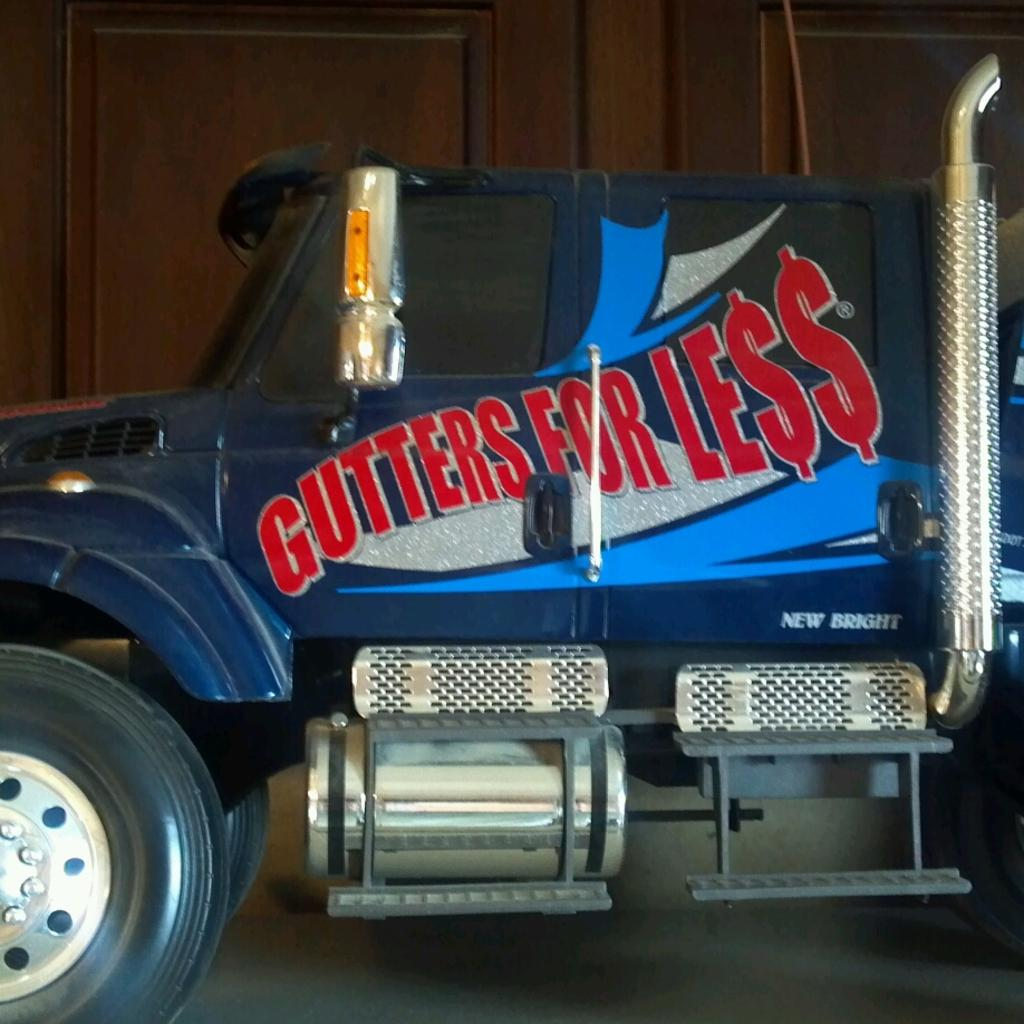What is the main subject of the image? There is a vehicle in the image. Can you describe any specific features of the vehicle? The vehicle has some text on it. What type of surface is visible in the image? There is ground visible in the image. What kind of structure is present in the image? There is a wooden wall in the image. Is there anything associated with the wooden wall? Yes, there is an object associated with the wooden wall. What type of cap can be seen on the pickle in the image? There is no cap or pickle present in the image. How does the soap interact with the wooden wall in the image? There is no soap present in the image, so it cannot interact with the wooden wall. 